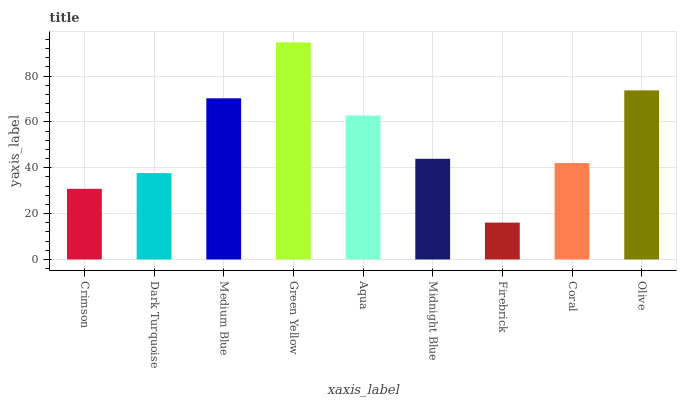Is Firebrick the minimum?
Answer yes or no. Yes. Is Green Yellow the maximum?
Answer yes or no. Yes. Is Dark Turquoise the minimum?
Answer yes or no. No. Is Dark Turquoise the maximum?
Answer yes or no. No. Is Dark Turquoise greater than Crimson?
Answer yes or no. Yes. Is Crimson less than Dark Turquoise?
Answer yes or no. Yes. Is Crimson greater than Dark Turquoise?
Answer yes or no. No. Is Dark Turquoise less than Crimson?
Answer yes or no. No. Is Midnight Blue the high median?
Answer yes or no. Yes. Is Midnight Blue the low median?
Answer yes or no. Yes. Is Firebrick the high median?
Answer yes or no. No. Is Aqua the low median?
Answer yes or no. No. 